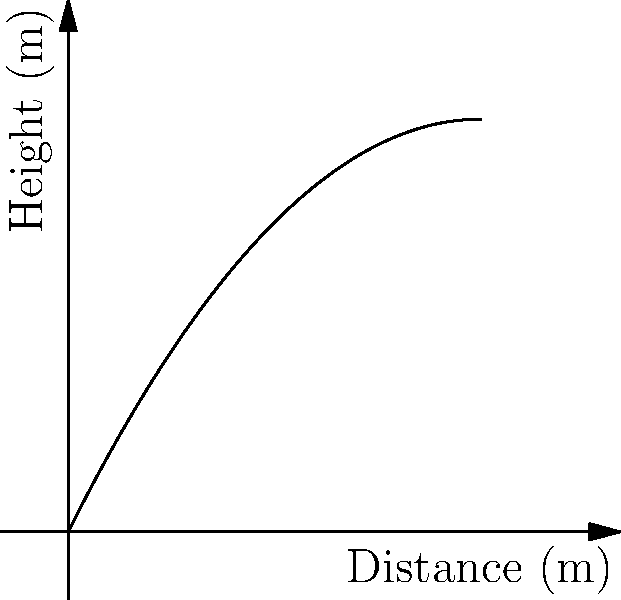As a professional editor preparing a book on military history, you encounter a section discussing the trajectory of cannonballs. The trajectory of a particular cannonball is modeled by the function $h(x) = -0.1x^2 + 2x$, where $h$ represents the height in meters and $x$ represents the horizontal distance in meters. At what horizontal distance does the cannonball hit the ground? To find the point where the cannonball hits the ground, we need to determine where the height $h(x)$ equals zero. This involves solving the quadratic equation:

1) Set $h(x) = 0$:
   $-0.1x^2 + 2x = 0$

2) Factor out the common factor $x$:
   $x(-0.1x + 2) = 0$

3) Use the zero product property. Either $x = 0$ or $-0.1x + 2 = 0$:
   $x = 0$ or $x = 20$

4) Since $x = 0$ represents the starting point, the impact point is at $x = 20$.

Therefore, the cannonball hits the ground at a horizontal distance of 20 meters.
Answer: 20 meters 